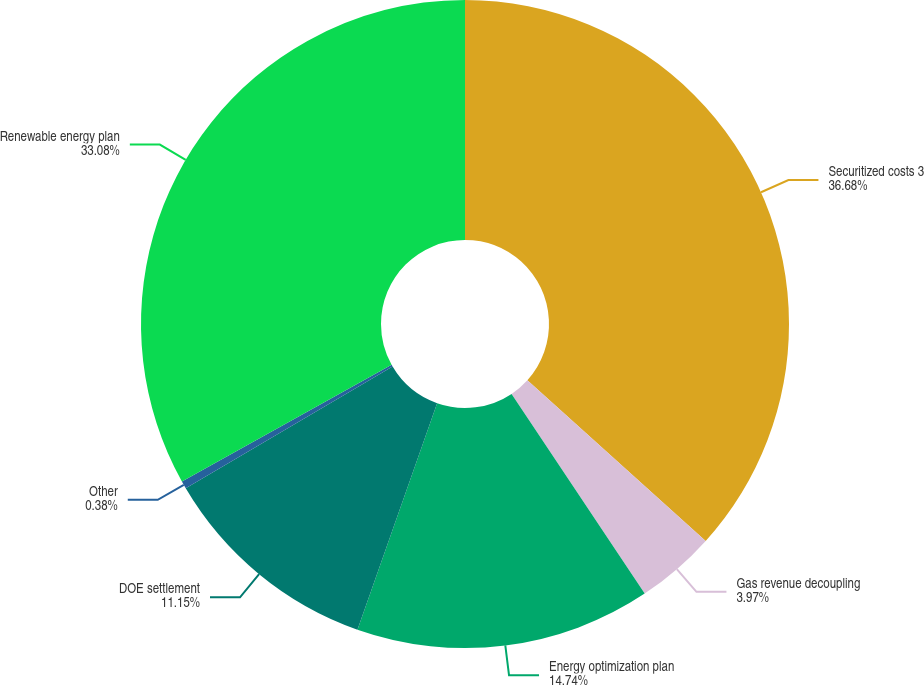<chart> <loc_0><loc_0><loc_500><loc_500><pie_chart><fcel>Securitized costs 3<fcel>Gas revenue decoupling<fcel>Energy optimization plan<fcel>DOE settlement<fcel>Other<fcel>Renewable energy plan<nl><fcel>36.67%<fcel>3.97%<fcel>14.74%<fcel>11.15%<fcel>0.38%<fcel>33.08%<nl></chart> 